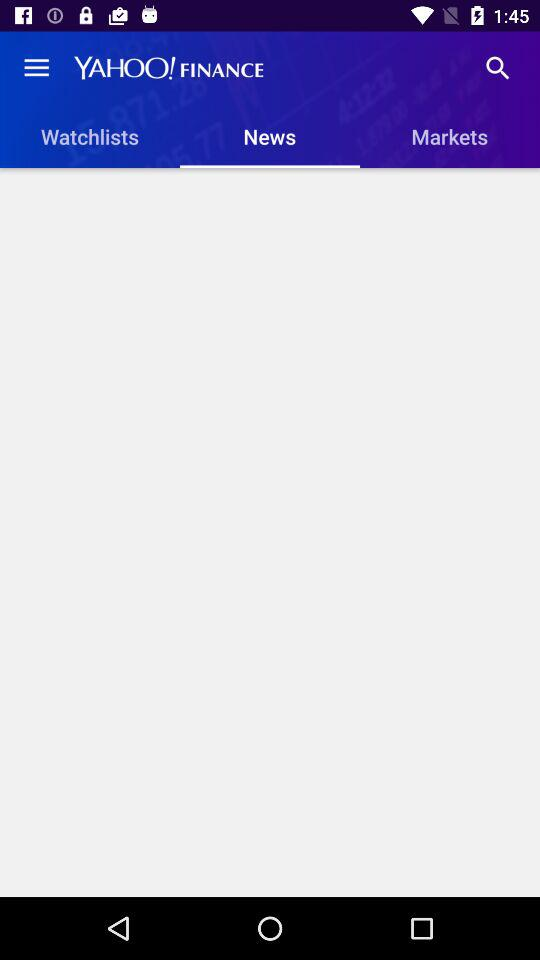What is the selected tab? The selected tab is "News". 